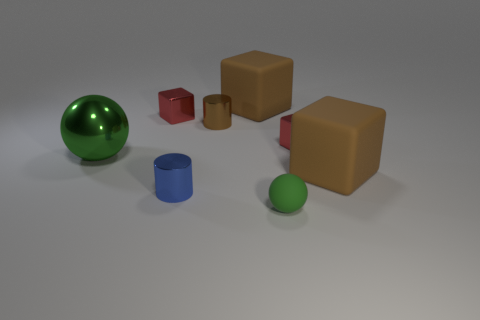Does the small green matte thing have the same shape as the big green shiny thing?
Ensure brevity in your answer.  Yes. What is the color of the matte cube that is left of the small green matte ball?
Your response must be concise. Brown. How many tiny shiny cylinders are there?
Give a very brief answer. 2. There is a tiny brown object that is made of the same material as the blue cylinder; what is its shape?
Offer a very short reply. Cylinder. Does the large cube that is in front of the tiny brown shiny cylinder have the same color as the large block that is behind the brown cylinder?
Ensure brevity in your answer.  Yes. Are there the same number of things left of the small green ball and small objects?
Your answer should be very brief. Yes. What number of metal objects are behind the big metallic thing?
Provide a succinct answer. 3. What is the size of the green metallic sphere?
Provide a short and direct response. Large. What color is the sphere that is made of the same material as the blue cylinder?
Offer a terse response. Green. How many brown cubes have the same size as the green metallic ball?
Offer a terse response. 2. 